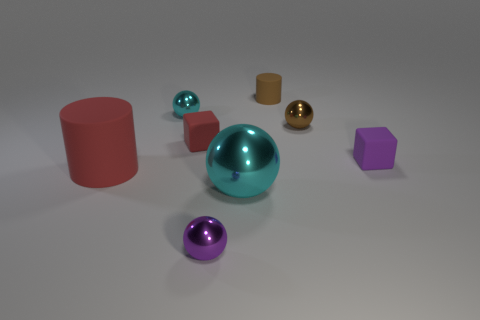Subtract all tiny metal balls. How many balls are left? 1 Subtract all yellow cylinders. How many cyan spheres are left? 2 Add 2 big cyan objects. How many objects exist? 10 Subtract all purple blocks. How many blocks are left? 1 Subtract all cylinders. How many objects are left? 6 Subtract 2 balls. How many balls are left? 2 Add 5 large purple metallic cylinders. How many large purple metallic cylinders exist? 5 Subtract 1 cyan balls. How many objects are left? 7 Subtract all yellow cylinders. Subtract all blue spheres. How many cylinders are left? 2 Subtract all big green metal spheres. Subtract all cyan metallic spheres. How many objects are left? 6 